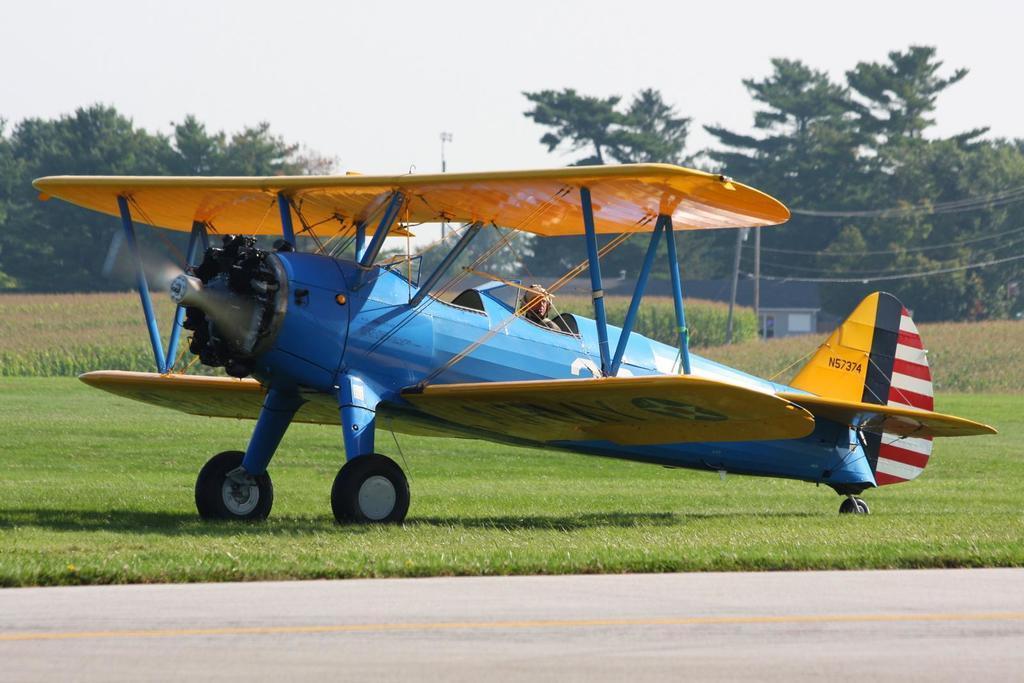Describe this image in one or two sentences. In this image I can see a road in the front and behind it I can see an open grass ground. I can also see an aircraft in the front and in it I can see one person is sitting. In the background I can see number of plants, number of trees, few poles and few wires on the right side. 